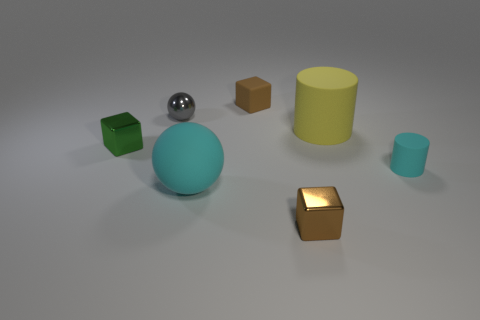Add 2 tiny cyan cylinders. How many objects exist? 9 Subtract all spheres. How many objects are left? 5 Add 6 tiny matte things. How many tiny matte things are left? 8 Add 4 purple balls. How many purple balls exist? 4 Subtract 0 red balls. How many objects are left? 7 Subtract all big cyan metal cylinders. Subtract all tiny cubes. How many objects are left? 4 